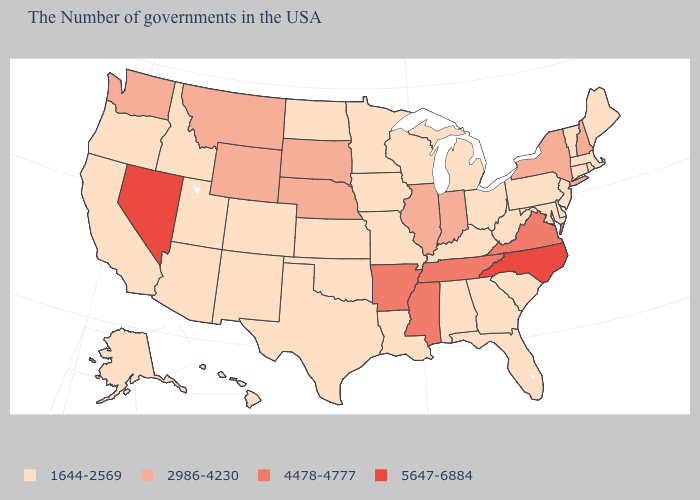What is the lowest value in states that border Pennsylvania?
Short answer required. 1644-2569. Does the map have missing data?
Be succinct. No. Does New Hampshire have a higher value than Michigan?
Keep it brief. Yes. What is the value of Maine?
Answer briefly. 1644-2569. How many symbols are there in the legend?
Keep it brief. 4. Among the states that border South Dakota , does Nebraska have the highest value?
Short answer required. Yes. Does Oklahoma have a higher value than Massachusetts?
Quick response, please. No. Among the states that border West Virginia , which have the lowest value?
Short answer required. Maryland, Pennsylvania, Ohio, Kentucky. Does Montana have a lower value than Illinois?
Quick response, please. No. Name the states that have a value in the range 4478-4777?
Write a very short answer. Virginia, Tennessee, Mississippi, Arkansas. Name the states that have a value in the range 5647-6884?
Give a very brief answer. North Carolina, Nevada. Name the states that have a value in the range 2986-4230?
Concise answer only. New Hampshire, New York, Indiana, Illinois, Nebraska, South Dakota, Wyoming, Montana, Washington. Does New Jersey have the highest value in the Northeast?
Write a very short answer. No. Does the map have missing data?
Keep it brief. No. Among the states that border South Dakota , which have the highest value?
Keep it brief. Nebraska, Wyoming, Montana. 